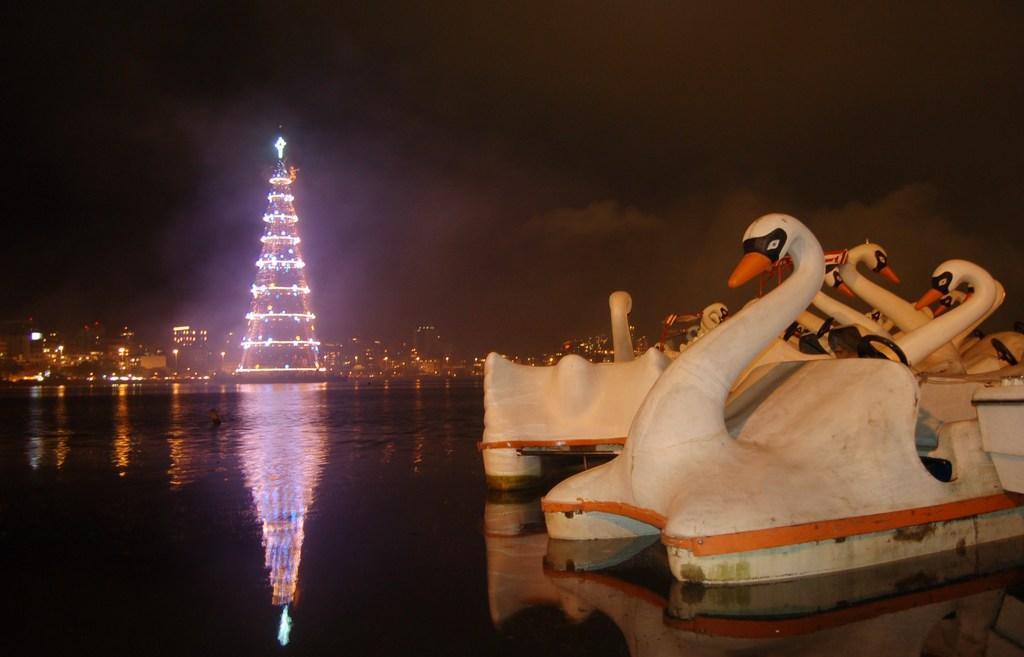How would you summarize this image in a sentence or two? On the right side of the image there are boats. At the bottom we can see river. In the background there are buildings, tower and sky. 